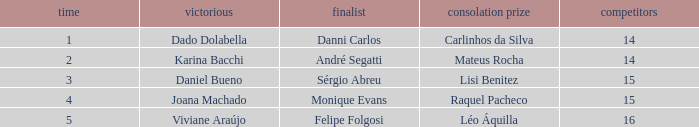How many contestants were there when the runner-up was Sérgio Abreu?  15.0. 